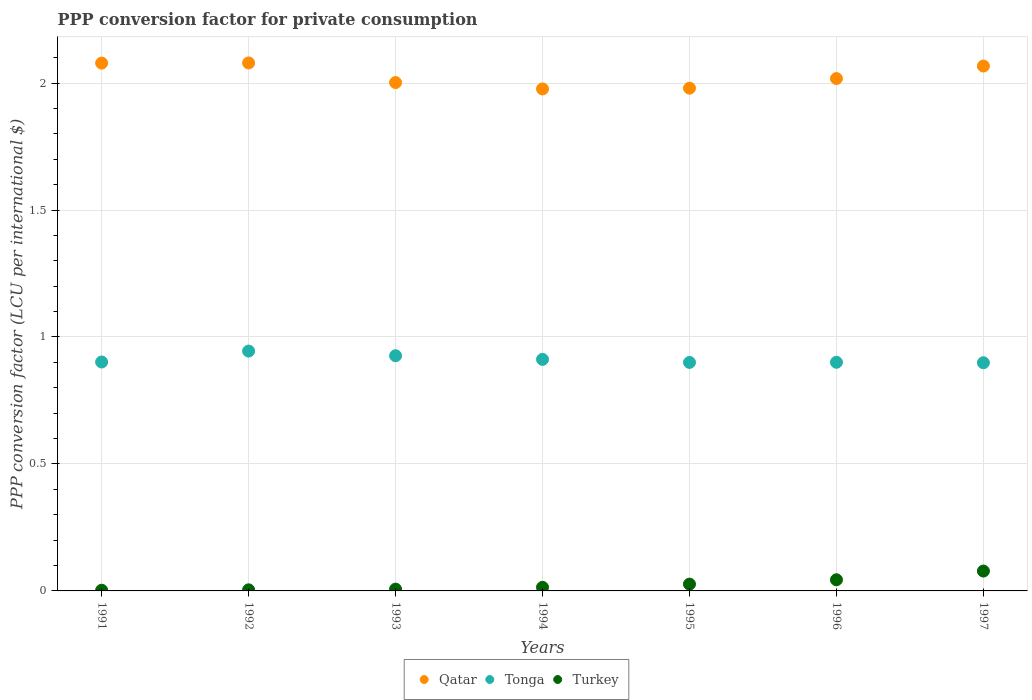Is the number of dotlines equal to the number of legend labels?
Make the answer very short. Yes. What is the PPP conversion factor for private consumption in Turkey in 1994?
Your response must be concise. 0.01. Across all years, what is the maximum PPP conversion factor for private consumption in Turkey?
Your answer should be compact. 0.08. Across all years, what is the minimum PPP conversion factor for private consumption in Qatar?
Give a very brief answer. 1.98. In which year was the PPP conversion factor for private consumption in Qatar minimum?
Your answer should be very brief. 1994. What is the total PPP conversion factor for private consumption in Turkey in the graph?
Ensure brevity in your answer.  0.18. What is the difference between the PPP conversion factor for private consumption in Qatar in 1996 and that in 1997?
Your answer should be very brief. -0.05. What is the difference between the PPP conversion factor for private consumption in Qatar in 1993 and the PPP conversion factor for private consumption in Tonga in 1997?
Make the answer very short. 1.1. What is the average PPP conversion factor for private consumption in Tonga per year?
Your answer should be very brief. 0.91. In the year 1996, what is the difference between the PPP conversion factor for private consumption in Turkey and PPP conversion factor for private consumption in Qatar?
Your answer should be compact. -1.97. In how many years, is the PPP conversion factor for private consumption in Turkey greater than 0.8 LCU?
Your answer should be very brief. 0. What is the ratio of the PPP conversion factor for private consumption in Turkey in 1991 to that in 1997?
Offer a terse response. 0.03. What is the difference between the highest and the second highest PPP conversion factor for private consumption in Qatar?
Your answer should be very brief. 0. What is the difference between the highest and the lowest PPP conversion factor for private consumption in Qatar?
Make the answer very short. 0.1. In how many years, is the PPP conversion factor for private consumption in Turkey greater than the average PPP conversion factor for private consumption in Turkey taken over all years?
Offer a terse response. 3. Is it the case that in every year, the sum of the PPP conversion factor for private consumption in Tonga and PPP conversion factor for private consumption in Turkey  is greater than the PPP conversion factor for private consumption in Qatar?
Offer a terse response. No. Does the PPP conversion factor for private consumption in Turkey monotonically increase over the years?
Your answer should be very brief. Yes. Is the PPP conversion factor for private consumption in Turkey strictly greater than the PPP conversion factor for private consumption in Tonga over the years?
Your answer should be very brief. No. How many years are there in the graph?
Provide a succinct answer. 7. Are the values on the major ticks of Y-axis written in scientific E-notation?
Keep it short and to the point. No. Does the graph contain any zero values?
Your answer should be very brief. No. Where does the legend appear in the graph?
Make the answer very short. Bottom center. How are the legend labels stacked?
Ensure brevity in your answer.  Horizontal. What is the title of the graph?
Keep it short and to the point. PPP conversion factor for private consumption. What is the label or title of the Y-axis?
Give a very brief answer. PPP conversion factor (LCU per international $). What is the PPP conversion factor (LCU per international $) of Qatar in 1991?
Offer a terse response. 2.08. What is the PPP conversion factor (LCU per international $) in Tonga in 1991?
Give a very brief answer. 0.9. What is the PPP conversion factor (LCU per international $) of Turkey in 1991?
Your answer should be compact. 0. What is the PPP conversion factor (LCU per international $) of Qatar in 1992?
Provide a short and direct response. 2.08. What is the PPP conversion factor (LCU per international $) in Tonga in 1992?
Make the answer very short. 0.94. What is the PPP conversion factor (LCU per international $) in Turkey in 1992?
Provide a short and direct response. 0. What is the PPP conversion factor (LCU per international $) in Qatar in 1993?
Offer a very short reply. 2. What is the PPP conversion factor (LCU per international $) of Tonga in 1993?
Ensure brevity in your answer.  0.93. What is the PPP conversion factor (LCU per international $) of Turkey in 1993?
Your answer should be compact. 0.01. What is the PPP conversion factor (LCU per international $) in Qatar in 1994?
Offer a very short reply. 1.98. What is the PPP conversion factor (LCU per international $) in Tonga in 1994?
Offer a terse response. 0.91. What is the PPP conversion factor (LCU per international $) of Turkey in 1994?
Give a very brief answer. 0.01. What is the PPP conversion factor (LCU per international $) in Qatar in 1995?
Ensure brevity in your answer.  1.98. What is the PPP conversion factor (LCU per international $) of Tonga in 1995?
Your answer should be compact. 0.9. What is the PPP conversion factor (LCU per international $) in Turkey in 1995?
Keep it short and to the point. 0.03. What is the PPP conversion factor (LCU per international $) of Qatar in 1996?
Give a very brief answer. 2.02. What is the PPP conversion factor (LCU per international $) of Tonga in 1996?
Make the answer very short. 0.9. What is the PPP conversion factor (LCU per international $) in Turkey in 1996?
Offer a terse response. 0.04. What is the PPP conversion factor (LCU per international $) of Qatar in 1997?
Provide a succinct answer. 2.07. What is the PPP conversion factor (LCU per international $) in Tonga in 1997?
Your answer should be compact. 0.9. What is the PPP conversion factor (LCU per international $) in Turkey in 1997?
Ensure brevity in your answer.  0.08. Across all years, what is the maximum PPP conversion factor (LCU per international $) of Qatar?
Your answer should be very brief. 2.08. Across all years, what is the maximum PPP conversion factor (LCU per international $) in Tonga?
Keep it short and to the point. 0.94. Across all years, what is the maximum PPP conversion factor (LCU per international $) of Turkey?
Keep it short and to the point. 0.08. Across all years, what is the minimum PPP conversion factor (LCU per international $) of Qatar?
Keep it short and to the point. 1.98. Across all years, what is the minimum PPP conversion factor (LCU per international $) in Tonga?
Your answer should be compact. 0.9. Across all years, what is the minimum PPP conversion factor (LCU per international $) in Turkey?
Your answer should be very brief. 0. What is the total PPP conversion factor (LCU per international $) in Qatar in the graph?
Keep it short and to the point. 14.2. What is the total PPP conversion factor (LCU per international $) in Tonga in the graph?
Give a very brief answer. 6.38. What is the total PPP conversion factor (LCU per international $) in Turkey in the graph?
Your answer should be very brief. 0.18. What is the difference between the PPP conversion factor (LCU per international $) in Qatar in 1991 and that in 1992?
Offer a very short reply. -0. What is the difference between the PPP conversion factor (LCU per international $) in Tonga in 1991 and that in 1992?
Give a very brief answer. -0.04. What is the difference between the PPP conversion factor (LCU per international $) in Turkey in 1991 and that in 1992?
Provide a short and direct response. -0. What is the difference between the PPP conversion factor (LCU per international $) of Qatar in 1991 and that in 1993?
Your answer should be compact. 0.08. What is the difference between the PPP conversion factor (LCU per international $) of Tonga in 1991 and that in 1993?
Your answer should be very brief. -0.02. What is the difference between the PPP conversion factor (LCU per international $) of Turkey in 1991 and that in 1993?
Make the answer very short. -0. What is the difference between the PPP conversion factor (LCU per international $) in Qatar in 1991 and that in 1994?
Your response must be concise. 0.1. What is the difference between the PPP conversion factor (LCU per international $) in Tonga in 1991 and that in 1994?
Ensure brevity in your answer.  -0.01. What is the difference between the PPP conversion factor (LCU per international $) in Turkey in 1991 and that in 1994?
Give a very brief answer. -0.01. What is the difference between the PPP conversion factor (LCU per international $) in Qatar in 1991 and that in 1995?
Your answer should be very brief. 0.1. What is the difference between the PPP conversion factor (LCU per international $) of Tonga in 1991 and that in 1995?
Ensure brevity in your answer.  0. What is the difference between the PPP conversion factor (LCU per international $) of Turkey in 1991 and that in 1995?
Ensure brevity in your answer.  -0.02. What is the difference between the PPP conversion factor (LCU per international $) of Qatar in 1991 and that in 1996?
Keep it short and to the point. 0.06. What is the difference between the PPP conversion factor (LCU per international $) in Tonga in 1991 and that in 1996?
Offer a terse response. 0. What is the difference between the PPP conversion factor (LCU per international $) of Turkey in 1991 and that in 1996?
Your response must be concise. -0.04. What is the difference between the PPP conversion factor (LCU per international $) of Qatar in 1991 and that in 1997?
Provide a succinct answer. 0.01. What is the difference between the PPP conversion factor (LCU per international $) in Tonga in 1991 and that in 1997?
Make the answer very short. 0. What is the difference between the PPP conversion factor (LCU per international $) of Turkey in 1991 and that in 1997?
Your answer should be compact. -0.08. What is the difference between the PPP conversion factor (LCU per international $) of Qatar in 1992 and that in 1993?
Give a very brief answer. 0.08. What is the difference between the PPP conversion factor (LCU per international $) in Tonga in 1992 and that in 1993?
Your answer should be very brief. 0.02. What is the difference between the PPP conversion factor (LCU per international $) of Turkey in 1992 and that in 1993?
Your response must be concise. -0. What is the difference between the PPP conversion factor (LCU per international $) in Qatar in 1992 and that in 1994?
Your answer should be compact. 0.1. What is the difference between the PPP conversion factor (LCU per international $) in Tonga in 1992 and that in 1994?
Give a very brief answer. 0.03. What is the difference between the PPP conversion factor (LCU per international $) in Turkey in 1992 and that in 1994?
Offer a terse response. -0.01. What is the difference between the PPP conversion factor (LCU per international $) of Qatar in 1992 and that in 1995?
Your answer should be very brief. 0.1. What is the difference between the PPP conversion factor (LCU per international $) in Tonga in 1992 and that in 1995?
Your response must be concise. 0.04. What is the difference between the PPP conversion factor (LCU per international $) in Turkey in 1992 and that in 1995?
Ensure brevity in your answer.  -0.02. What is the difference between the PPP conversion factor (LCU per international $) of Qatar in 1992 and that in 1996?
Your answer should be very brief. 0.06. What is the difference between the PPP conversion factor (LCU per international $) of Tonga in 1992 and that in 1996?
Provide a succinct answer. 0.04. What is the difference between the PPP conversion factor (LCU per international $) in Turkey in 1992 and that in 1996?
Make the answer very short. -0.04. What is the difference between the PPP conversion factor (LCU per international $) in Qatar in 1992 and that in 1997?
Make the answer very short. 0.01. What is the difference between the PPP conversion factor (LCU per international $) in Tonga in 1992 and that in 1997?
Your answer should be compact. 0.05. What is the difference between the PPP conversion factor (LCU per international $) in Turkey in 1992 and that in 1997?
Give a very brief answer. -0.07. What is the difference between the PPP conversion factor (LCU per international $) of Qatar in 1993 and that in 1994?
Provide a succinct answer. 0.03. What is the difference between the PPP conversion factor (LCU per international $) in Tonga in 1993 and that in 1994?
Offer a terse response. 0.01. What is the difference between the PPP conversion factor (LCU per international $) in Turkey in 1993 and that in 1994?
Ensure brevity in your answer.  -0.01. What is the difference between the PPP conversion factor (LCU per international $) of Qatar in 1993 and that in 1995?
Keep it short and to the point. 0.02. What is the difference between the PPP conversion factor (LCU per international $) of Tonga in 1993 and that in 1995?
Provide a succinct answer. 0.03. What is the difference between the PPP conversion factor (LCU per international $) of Turkey in 1993 and that in 1995?
Offer a very short reply. -0.02. What is the difference between the PPP conversion factor (LCU per international $) of Qatar in 1993 and that in 1996?
Your answer should be compact. -0.02. What is the difference between the PPP conversion factor (LCU per international $) in Tonga in 1993 and that in 1996?
Offer a terse response. 0.03. What is the difference between the PPP conversion factor (LCU per international $) in Turkey in 1993 and that in 1996?
Offer a terse response. -0.04. What is the difference between the PPP conversion factor (LCU per international $) in Qatar in 1993 and that in 1997?
Your answer should be very brief. -0.07. What is the difference between the PPP conversion factor (LCU per international $) in Tonga in 1993 and that in 1997?
Your response must be concise. 0.03. What is the difference between the PPP conversion factor (LCU per international $) in Turkey in 1993 and that in 1997?
Give a very brief answer. -0.07. What is the difference between the PPP conversion factor (LCU per international $) of Qatar in 1994 and that in 1995?
Your answer should be compact. -0. What is the difference between the PPP conversion factor (LCU per international $) of Tonga in 1994 and that in 1995?
Provide a succinct answer. 0.01. What is the difference between the PPP conversion factor (LCU per international $) of Turkey in 1994 and that in 1995?
Provide a succinct answer. -0.01. What is the difference between the PPP conversion factor (LCU per international $) of Qatar in 1994 and that in 1996?
Keep it short and to the point. -0.04. What is the difference between the PPP conversion factor (LCU per international $) in Tonga in 1994 and that in 1996?
Make the answer very short. 0.01. What is the difference between the PPP conversion factor (LCU per international $) of Turkey in 1994 and that in 1996?
Keep it short and to the point. -0.03. What is the difference between the PPP conversion factor (LCU per international $) in Qatar in 1994 and that in 1997?
Provide a succinct answer. -0.09. What is the difference between the PPP conversion factor (LCU per international $) of Tonga in 1994 and that in 1997?
Provide a succinct answer. 0.01. What is the difference between the PPP conversion factor (LCU per international $) of Turkey in 1994 and that in 1997?
Your answer should be very brief. -0.06. What is the difference between the PPP conversion factor (LCU per international $) in Qatar in 1995 and that in 1996?
Your answer should be very brief. -0.04. What is the difference between the PPP conversion factor (LCU per international $) of Tonga in 1995 and that in 1996?
Offer a terse response. -0. What is the difference between the PPP conversion factor (LCU per international $) of Turkey in 1995 and that in 1996?
Your response must be concise. -0.02. What is the difference between the PPP conversion factor (LCU per international $) of Qatar in 1995 and that in 1997?
Your answer should be compact. -0.09. What is the difference between the PPP conversion factor (LCU per international $) in Tonga in 1995 and that in 1997?
Give a very brief answer. 0. What is the difference between the PPP conversion factor (LCU per international $) of Turkey in 1995 and that in 1997?
Give a very brief answer. -0.05. What is the difference between the PPP conversion factor (LCU per international $) in Qatar in 1996 and that in 1997?
Your answer should be very brief. -0.05. What is the difference between the PPP conversion factor (LCU per international $) of Tonga in 1996 and that in 1997?
Offer a very short reply. 0. What is the difference between the PPP conversion factor (LCU per international $) in Turkey in 1996 and that in 1997?
Provide a short and direct response. -0.03. What is the difference between the PPP conversion factor (LCU per international $) in Qatar in 1991 and the PPP conversion factor (LCU per international $) in Tonga in 1992?
Offer a terse response. 1.13. What is the difference between the PPP conversion factor (LCU per international $) in Qatar in 1991 and the PPP conversion factor (LCU per international $) in Turkey in 1992?
Provide a succinct answer. 2.07. What is the difference between the PPP conversion factor (LCU per international $) of Tonga in 1991 and the PPP conversion factor (LCU per international $) of Turkey in 1992?
Provide a succinct answer. 0.9. What is the difference between the PPP conversion factor (LCU per international $) in Qatar in 1991 and the PPP conversion factor (LCU per international $) in Tonga in 1993?
Offer a terse response. 1.15. What is the difference between the PPP conversion factor (LCU per international $) in Qatar in 1991 and the PPP conversion factor (LCU per international $) in Turkey in 1993?
Your response must be concise. 2.07. What is the difference between the PPP conversion factor (LCU per international $) of Tonga in 1991 and the PPP conversion factor (LCU per international $) of Turkey in 1993?
Offer a terse response. 0.89. What is the difference between the PPP conversion factor (LCU per international $) of Qatar in 1991 and the PPP conversion factor (LCU per international $) of Tonga in 1994?
Make the answer very short. 1.17. What is the difference between the PPP conversion factor (LCU per international $) of Qatar in 1991 and the PPP conversion factor (LCU per international $) of Turkey in 1994?
Provide a short and direct response. 2.06. What is the difference between the PPP conversion factor (LCU per international $) of Tonga in 1991 and the PPP conversion factor (LCU per international $) of Turkey in 1994?
Make the answer very short. 0.89. What is the difference between the PPP conversion factor (LCU per international $) of Qatar in 1991 and the PPP conversion factor (LCU per international $) of Tonga in 1995?
Provide a short and direct response. 1.18. What is the difference between the PPP conversion factor (LCU per international $) in Qatar in 1991 and the PPP conversion factor (LCU per international $) in Turkey in 1995?
Make the answer very short. 2.05. What is the difference between the PPP conversion factor (LCU per international $) of Tonga in 1991 and the PPP conversion factor (LCU per international $) of Turkey in 1995?
Provide a succinct answer. 0.87. What is the difference between the PPP conversion factor (LCU per international $) in Qatar in 1991 and the PPP conversion factor (LCU per international $) in Tonga in 1996?
Give a very brief answer. 1.18. What is the difference between the PPP conversion factor (LCU per international $) in Qatar in 1991 and the PPP conversion factor (LCU per international $) in Turkey in 1996?
Provide a succinct answer. 2.03. What is the difference between the PPP conversion factor (LCU per international $) of Tonga in 1991 and the PPP conversion factor (LCU per international $) of Turkey in 1996?
Offer a terse response. 0.86. What is the difference between the PPP conversion factor (LCU per international $) of Qatar in 1991 and the PPP conversion factor (LCU per international $) of Tonga in 1997?
Offer a very short reply. 1.18. What is the difference between the PPP conversion factor (LCU per international $) of Qatar in 1991 and the PPP conversion factor (LCU per international $) of Turkey in 1997?
Provide a succinct answer. 2. What is the difference between the PPP conversion factor (LCU per international $) of Tonga in 1991 and the PPP conversion factor (LCU per international $) of Turkey in 1997?
Provide a succinct answer. 0.82. What is the difference between the PPP conversion factor (LCU per international $) in Qatar in 1992 and the PPP conversion factor (LCU per international $) in Tonga in 1993?
Your answer should be very brief. 1.15. What is the difference between the PPP conversion factor (LCU per international $) of Qatar in 1992 and the PPP conversion factor (LCU per international $) of Turkey in 1993?
Offer a very short reply. 2.07. What is the difference between the PPP conversion factor (LCU per international $) of Tonga in 1992 and the PPP conversion factor (LCU per international $) of Turkey in 1993?
Provide a short and direct response. 0.94. What is the difference between the PPP conversion factor (LCU per international $) in Qatar in 1992 and the PPP conversion factor (LCU per international $) in Tonga in 1994?
Offer a very short reply. 1.17. What is the difference between the PPP conversion factor (LCU per international $) in Qatar in 1992 and the PPP conversion factor (LCU per international $) in Turkey in 1994?
Offer a very short reply. 2.07. What is the difference between the PPP conversion factor (LCU per international $) of Tonga in 1992 and the PPP conversion factor (LCU per international $) of Turkey in 1994?
Your answer should be very brief. 0.93. What is the difference between the PPP conversion factor (LCU per international $) in Qatar in 1992 and the PPP conversion factor (LCU per international $) in Tonga in 1995?
Give a very brief answer. 1.18. What is the difference between the PPP conversion factor (LCU per international $) of Qatar in 1992 and the PPP conversion factor (LCU per international $) of Turkey in 1995?
Your answer should be compact. 2.05. What is the difference between the PPP conversion factor (LCU per international $) in Tonga in 1992 and the PPP conversion factor (LCU per international $) in Turkey in 1995?
Your response must be concise. 0.92. What is the difference between the PPP conversion factor (LCU per international $) in Qatar in 1992 and the PPP conversion factor (LCU per international $) in Tonga in 1996?
Offer a very short reply. 1.18. What is the difference between the PPP conversion factor (LCU per international $) in Qatar in 1992 and the PPP conversion factor (LCU per international $) in Turkey in 1996?
Your answer should be compact. 2.04. What is the difference between the PPP conversion factor (LCU per international $) of Tonga in 1992 and the PPP conversion factor (LCU per international $) of Turkey in 1996?
Provide a short and direct response. 0.9. What is the difference between the PPP conversion factor (LCU per international $) of Qatar in 1992 and the PPP conversion factor (LCU per international $) of Tonga in 1997?
Make the answer very short. 1.18. What is the difference between the PPP conversion factor (LCU per international $) in Qatar in 1992 and the PPP conversion factor (LCU per international $) in Turkey in 1997?
Your answer should be very brief. 2. What is the difference between the PPP conversion factor (LCU per international $) of Tonga in 1992 and the PPP conversion factor (LCU per international $) of Turkey in 1997?
Your answer should be compact. 0.87. What is the difference between the PPP conversion factor (LCU per international $) of Qatar in 1993 and the PPP conversion factor (LCU per international $) of Tonga in 1994?
Offer a terse response. 1.09. What is the difference between the PPP conversion factor (LCU per international $) in Qatar in 1993 and the PPP conversion factor (LCU per international $) in Turkey in 1994?
Provide a succinct answer. 1.99. What is the difference between the PPP conversion factor (LCU per international $) in Tonga in 1993 and the PPP conversion factor (LCU per international $) in Turkey in 1994?
Ensure brevity in your answer.  0.91. What is the difference between the PPP conversion factor (LCU per international $) of Qatar in 1993 and the PPP conversion factor (LCU per international $) of Tonga in 1995?
Make the answer very short. 1.1. What is the difference between the PPP conversion factor (LCU per international $) of Qatar in 1993 and the PPP conversion factor (LCU per international $) of Turkey in 1995?
Provide a succinct answer. 1.98. What is the difference between the PPP conversion factor (LCU per international $) in Tonga in 1993 and the PPP conversion factor (LCU per international $) in Turkey in 1995?
Your answer should be compact. 0.9. What is the difference between the PPP conversion factor (LCU per international $) in Qatar in 1993 and the PPP conversion factor (LCU per international $) in Tonga in 1996?
Offer a very short reply. 1.1. What is the difference between the PPP conversion factor (LCU per international $) of Qatar in 1993 and the PPP conversion factor (LCU per international $) of Turkey in 1996?
Provide a succinct answer. 1.96. What is the difference between the PPP conversion factor (LCU per international $) of Tonga in 1993 and the PPP conversion factor (LCU per international $) of Turkey in 1996?
Make the answer very short. 0.88. What is the difference between the PPP conversion factor (LCU per international $) of Qatar in 1993 and the PPP conversion factor (LCU per international $) of Tonga in 1997?
Your response must be concise. 1.1. What is the difference between the PPP conversion factor (LCU per international $) in Qatar in 1993 and the PPP conversion factor (LCU per international $) in Turkey in 1997?
Ensure brevity in your answer.  1.92. What is the difference between the PPP conversion factor (LCU per international $) in Tonga in 1993 and the PPP conversion factor (LCU per international $) in Turkey in 1997?
Your response must be concise. 0.85. What is the difference between the PPP conversion factor (LCU per international $) in Qatar in 1994 and the PPP conversion factor (LCU per international $) in Tonga in 1995?
Provide a succinct answer. 1.08. What is the difference between the PPP conversion factor (LCU per international $) of Qatar in 1994 and the PPP conversion factor (LCU per international $) of Turkey in 1995?
Your response must be concise. 1.95. What is the difference between the PPP conversion factor (LCU per international $) in Tonga in 1994 and the PPP conversion factor (LCU per international $) in Turkey in 1995?
Your response must be concise. 0.89. What is the difference between the PPP conversion factor (LCU per international $) of Qatar in 1994 and the PPP conversion factor (LCU per international $) of Tonga in 1996?
Provide a short and direct response. 1.08. What is the difference between the PPP conversion factor (LCU per international $) of Qatar in 1994 and the PPP conversion factor (LCU per international $) of Turkey in 1996?
Offer a terse response. 1.93. What is the difference between the PPP conversion factor (LCU per international $) in Tonga in 1994 and the PPP conversion factor (LCU per international $) in Turkey in 1996?
Offer a very short reply. 0.87. What is the difference between the PPP conversion factor (LCU per international $) of Qatar in 1994 and the PPP conversion factor (LCU per international $) of Tonga in 1997?
Your answer should be compact. 1.08. What is the difference between the PPP conversion factor (LCU per international $) of Qatar in 1994 and the PPP conversion factor (LCU per international $) of Turkey in 1997?
Keep it short and to the point. 1.9. What is the difference between the PPP conversion factor (LCU per international $) in Tonga in 1994 and the PPP conversion factor (LCU per international $) in Turkey in 1997?
Make the answer very short. 0.83. What is the difference between the PPP conversion factor (LCU per international $) of Qatar in 1995 and the PPP conversion factor (LCU per international $) of Tonga in 1996?
Provide a short and direct response. 1.08. What is the difference between the PPP conversion factor (LCU per international $) of Qatar in 1995 and the PPP conversion factor (LCU per international $) of Turkey in 1996?
Your response must be concise. 1.94. What is the difference between the PPP conversion factor (LCU per international $) of Tonga in 1995 and the PPP conversion factor (LCU per international $) of Turkey in 1996?
Provide a short and direct response. 0.86. What is the difference between the PPP conversion factor (LCU per international $) in Qatar in 1995 and the PPP conversion factor (LCU per international $) in Tonga in 1997?
Your response must be concise. 1.08. What is the difference between the PPP conversion factor (LCU per international $) in Qatar in 1995 and the PPP conversion factor (LCU per international $) in Turkey in 1997?
Your answer should be compact. 1.9. What is the difference between the PPP conversion factor (LCU per international $) of Tonga in 1995 and the PPP conversion factor (LCU per international $) of Turkey in 1997?
Provide a succinct answer. 0.82. What is the difference between the PPP conversion factor (LCU per international $) of Qatar in 1996 and the PPP conversion factor (LCU per international $) of Tonga in 1997?
Your answer should be very brief. 1.12. What is the difference between the PPP conversion factor (LCU per international $) of Qatar in 1996 and the PPP conversion factor (LCU per international $) of Turkey in 1997?
Make the answer very short. 1.94. What is the difference between the PPP conversion factor (LCU per international $) in Tonga in 1996 and the PPP conversion factor (LCU per international $) in Turkey in 1997?
Ensure brevity in your answer.  0.82. What is the average PPP conversion factor (LCU per international $) of Qatar per year?
Offer a terse response. 2.03. What is the average PPP conversion factor (LCU per international $) in Tonga per year?
Your response must be concise. 0.91. What is the average PPP conversion factor (LCU per international $) in Turkey per year?
Provide a short and direct response. 0.03. In the year 1991, what is the difference between the PPP conversion factor (LCU per international $) in Qatar and PPP conversion factor (LCU per international $) in Tonga?
Give a very brief answer. 1.18. In the year 1991, what is the difference between the PPP conversion factor (LCU per international $) in Qatar and PPP conversion factor (LCU per international $) in Turkey?
Make the answer very short. 2.08. In the year 1991, what is the difference between the PPP conversion factor (LCU per international $) of Tonga and PPP conversion factor (LCU per international $) of Turkey?
Provide a succinct answer. 0.9. In the year 1992, what is the difference between the PPP conversion factor (LCU per international $) in Qatar and PPP conversion factor (LCU per international $) in Tonga?
Make the answer very short. 1.13. In the year 1992, what is the difference between the PPP conversion factor (LCU per international $) of Qatar and PPP conversion factor (LCU per international $) of Turkey?
Provide a short and direct response. 2.08. In the year 1992, what is the difference between the PPP conversion factor (LCU per international $) in Tonga and PPP conversion factor (LCU per international $) in Turkey?
Make the answer very short. 0.94. In the year 1993, what is the difference between the PPP conversion factor (LCU per international $) in Qatar and PPP conversion factor (LCU per international $) in Tonga?
Your answer should be very brief. 1.08. In the year 1993, what is the difference between the PPP conversion factor (LCU per international $) of Qatar and PPP conversion factor (LCU per international $) of Turkey?
Make the answer very short. 2. In the year 1993, what is the difference between the PPP conversion factor (LCU per international $) of Tonga and PPP conversion factor (LCU per international $) of Turkey?
Keep it short and to the point. 0.92. In the year 1994, what is the difference between the PPP conversion factor (LCU per international $) of Qatar and PPP conversion factor (LCU per international $) of Tonga?
Offer a very short reply. 1.07. In the year 1994, what is the difference between the PPP conversion factor (LCU per international $) in Qatar and PPP conversion factor (LCU per international $) in Turkey?
Make the answer very short. 1.96. In the year 1994, what is the difference between the PPP conversion factor (LCU per international $) in Tonga and PPP conversion factor (LCU per international $) in Turkey?
Offer a terse response. 0.9. In the year 1995, what is the difference between the PPP conversion factor (LCU per international $) of Qatar and PPP conversion factor (LCU per international $) of Tonga?
Provide a short and direct response. 1.08. In the year 1995, what is the difference between the PPP conversion factor (LCU per international $) of Qatar and PPP conversion factor (LCU per international $) of Turkey?
Give a very brief answer. 1.95. In the year 1995, what is the difference between the PPP conversion factor (LCU per international $) in Tonga and PPP conversion factor (LCU per international $) in Turkey?
Offer a very short reply. 0.87. In the year 1996, what is the difference between the PPP conversion factor (LCU per international $) in Qatar and PPP conversion factor (LCU per international $) in Tonga?
Ensure brevity in your answer.  1.12. In the year 1996, what is the difference between the PPP conversion factor (LCU per international $) in Qatar and PPP conversion factor (LCU per international $) in Turkey?
Give a very brief answer. 1.97. In the year 1996, what is the difference between the PPP conversion factor (LCU per international $) in Tonga and PPP conversion factor (LCU per international $) in Turkey?
Make the answer very short. 0.86. In the year 1997, what is the difference between the PPP conversion factor (LCU per international $) in Qatar and PPP conversion factor (LCU per international $) in Tonga?
Give a very brief answer. 1.17. In the year 1997, what is the difference between the PPP conversion factor (LCU per international $) in Qatar and PPP conversion factor (LCU per international $) in Turkey?
Offer a very short reply. 1.99. In the year 1997, what is the difference between the PPP conversion factor (LCU per international $) in Tonga and PPP conversion factor (LCU per international $) in Turkey?
Offer a very short reply. 0.82. What is the ratio of the PPP conversion factor (LCU per international $) of Tonga in 1991 to that in 1992?
Offer a terse response. 0.95. What is the ratio of the PPP conversion factor (LCU per international $) in Turkey in 1991 to that in 1992?
Your answer should be compact. 0.62. What is the ratio of the PPP conversion factor (LCU per international $) of Qatar in 1991 to that in 1993?
Ensure brevity in your answer.  1.04. What is the ratio of the PPP conversion factor (LCU per international $) in Tonga in 1991 to that in 1993?
Give a very brief answer. 0.97. What is the ratio of the PPP conversion factor (LCU per international $) of Turkey in 1991 to that in 1993?
Keep it short and to the point. 0.38. What is the ratio of the PPP conversion factor (LCU per international $) in Qatar in 1991 to that in 1994?
Give a very brief answer. 1.05. What is the ratio of the PPP conversion factor (LCU per international $) of Tonga in 1991 to that in 1994?
Offer a very short reply. 0.99. What is the ratio of the PPP conversion factor (LCU per international $) of Turkey in 1991 to that in 1994?
Your answer should be compact. 0.19. What is the ratio of the PPP conversion factor (LCU per international $) in Qatar in 1991 to that in 1995?
Provide a succinct answer. 1.05. What is the ratio of the PPP conversion factor (LCU per international $) in Tonga in 1991 to that in 1995?
Offer a terse response. 1. What is the ratio of the PPP conversion factor (LCU per international $) in Turkey in 1991 to that in 1995?
Offer a very short reply. 0.1. What is the ratio of the PPP conversion factor (LCU per international $) of Qatar in 1991 to that in 1996?
Offer a very short reply. 1.03. What is the ratio of the PPP conversion factor (LCU per international $) of Tonga in 1991 to that in 1996?
Your response must be concise. 1. What is the ratio of the PPP conversion factor (LCU per international $) of Turkey in 1991 to that in 1996?
Keep it short and to the point. 0.06. What is the ratio of the PPP conversion factor (LCU per international $) of Qatar in 1991 to that in 1997?
Ensure brevity in your answer.  1.01. What is the ratio of the PPP conversion factor (LCU per international $) of Tonga in 1991 to that in 1997?
Make the answer very short. 1. What is the ratio of the PPP conversion factor (LCU per international $) in Turkey in 1991 to that in 1997?
Provide a short and direct response. 0.03. What is the ratio of the PPP conversion factor (LCU per international $) in Qatar in 1992 to that in 1993?
Provide a short and direct response. 1.04. What is the ratio of the PPP conversion factor (LCU per international $) of Tonga in 1992 to that in 1993?
Your answer should be compact. 1.02. What is the ratio of the PPP conversion factor (LCU per international $) of Turkey in 1992 to that in 1993?
Ensure brevity in your answer.  0.62. What is the ratio of the PPP conversion factor (LCU per international $) in Qatar in 1992 to that in 1994?
Provide a succinct answer. 1.05. What is the ratio of the PPP conversion factor (LCU per international $) in Tonga in 1992 to that in 1994?
Your answer should be very brief. 1.04. What is the ratio of the PPP conversion factor (LCU per international $) of Turkey in 1992 to that in 1994?
Make the answer very short. 0.3. What is the ratio of the PPP conversion factor (LCU per international $) in Qatar in 1992 to that in 1995?
Give a very brief answer. 1.05. What is the ratio of the PPP conversion factor (LCU per international $) in Tonga in 1992 to that in 1995?
Offer a very short reply. 1.05. What is the ratio of the PPP conversion factor (LCU per international $) of Turkey in 1992 to that in 1995?
Offer a very short reply. 0.16. What is the ratio of the PPP conversion factor (LCU per international $) of Qatar in 1992 to that in 1996?
Your answer should be compact. 1.03. What is the ratio of the PPP conversion factor (LCU per international $) in Tonga in 1992 to that in 1996?
Give a very brief answer. 1.05. What is the ratio of the PPP conversion factor (LCU per international $) of Turkey in 1992 to that in 1996?
Ensure brevity in your answer.  0.1. What is the ratio of the PPP conversion factor (LCU per international $) in Qatar in 1992 to that in 1997?
Keep it short and to the point. 1.01. What is the ratio of the PPP conversion factor (LCU per international $) of Tonga in 1992 to that in 1997?
Your answer should be very brief. 1.05. What is the ratio of the PPP conversion factor (LCU per international $) of Turkey in 1992 to that in 1997?
Offer a terse response. 0.05. What is the ratio of the PPP conversion factor (LCU per international $) of Qatar in 1993 to that in 1994?
Provide a succinct answer. 1.01. What is the ratio of the PPP conversion factor (LCU per international $) of Tonga in 1993 to that in 1994?
Offer a very short reply. 1.02. What is the ratio of the PPP conversion factor (LCU per international $) of Turkey in 1993 to that in 1994?
Ensure brevity in your answer.  0.49. What is the ratio of the PPP conversion factor (LCU per international $) of Qatar in 1993 to that in 1995?
Give a very brief answer. 1.01. What is the ratio of the PPP conversion factor (LCU per international $) of Tonga in 1993 to that in 1995?
Your answer should be compact. 1.03. What is the ratio of the PPP conversion factor (LCU per international $) of Turkey in 1993 to that in 1995?
Your answer should be compact. 0.26. What is the ratio of the PPP conversion factor (LCU per international $) of Qatar in 1993 to that in 1996?
Your answer should be very brief. 0.99. What is the ratio of the PPP conversion factor (LCU per international $) of Tonga in 1993 to that in 1996?
Make the answer very short. 1.03. What is the ratio of the PPP conversion factor (LCU per international $) in Turkey in 1993 to that in 1996?
Your answer should be compact. 0.16. What is the ratio of the PPP conversion factor (LCU per international $) in Qatar in 1993 to that in 1997?
Offer a terse response. 0.97. What is the ratio of the PPP conversion factor (LCU per international $) in Tonga in 1993 to that in 1997?
Keep it short and to the point. 1.03. What is the ratio of the PPP conversion factor (LCU per international $) of Turkey in 1993 to that in 1997?
Provide a short and direct response. 0.09. What is the ratio of the PPP conversion factor (LCU per international $) in Tonga in 1994 to that in 1995?
Offer a very short reply. 1.01. What is the ratio of the PPP conversion factor (LCU per international $) of Turkey in 1994 to that in 1995?
Offer a terse response. 0.53. What is the ratio of the PPP conversion factor (LCU per international $) in Qatar in 1994 to that in 1996?
Provide a short and direct response. 0.98. What is the ratio of the PPP conversion factor (LCU per international $) of Tonga in 1994 to that in 1996?
Provide a succinct answer. 1.01. What is the ratio of the PPP conversion factor (LCU per international $) in Turkey in 1994 to that in 1996?
Give a very brief answer. 0.32. What is the ratio of the PPP conversion factor (LCU per international $) of Qatar in 1994 to that in 1997?
Your answer should be compact. 0.96. What is the ratio of the PPP conversion factor (LCU per international $) of Tonga in 1994 to that in 1997?
Ensure brevity in your answer.  1.01. What is the ratio of the PPP conversion factor (LCU per international $) in Turkey in 1994 to that in 1997?
Keep it short and to the point. 0.18. What is the ratio of the PPP conversion factor (LCU per international $) in Qatar in 1995 to that in 1996?
Your answer should be compact. 0.98. What is the ratio of the PPP conversion factor (LCU per international $) in Tonga in 1995 to that in 1996?
Offer a terse response. 1. What is the ratio of the PPP conversion factor (LCU per international $) in Turkey in 1995 to that in 1996?
Give a very brief answer. 0.61. What is the ratio of the PPP conversion factor (LCU per international $) in Qatar in 1995 to that in 1997?
Offer a very short reply. 0.96. What is the ratio of the PPP conversion factor (LCU per international $) of Turkey in 1995 to that in 1997?
Keep it short and to the point. 0.34. What is the ratio of the PPP conversion factor (LCU per international $) of Qatar in 1996 to that in 1997?
Provide a succinct answer. 0.98. What is the ratio of the PPP conversion factor (LCU per international $) in Turkey in 1996 to that in 1997?
Keep it short and to the point. 0.56. What is the difference between the highest and the second highest PPP conversion factor (LCU per international $) in Qatar?
Offer a terse response. 0. What is the difference between the highest and the second highest PPP conversion factor (LCU per international $) in Tonga?
Give a very brief answer. 0.02. What is the difference between the highest and the second highest PPP conversion factor (LCU per international $) in Turkey?
Make the answer very short. 0.03. What is the difference between the highest and the lowest PPP conversion factor (LCU per international $) of Qatar?
Make the answer very short. 0.1. What is the difference between the highest and the lowest PPP conversion factor (LCU per international $) in Tonga?
Offer a very short reply. 0.05. What is the difference between the highest and the lowest PPP conversion factor (LCU per international $) in Turkey?
Your answer should be very brief. 0.08. 